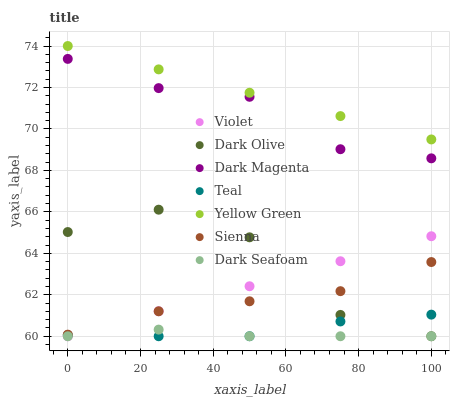Does Dark Seafoam have the minimum area under the curve?
Answer yes or no. Yes. Does Yellow Green have the maximum area under the curve?
Answer yes or no. Yes. Does Dark Olive have the minimum area under the curve?
Answer yes or no. No. Does Dark Olive have the maximum area under the curve?
Answer yes or no. No. Is Violet the smoothest?
Answer yes or no. Yes. Is Dark Olive the roughest?
Answer yes or no. Yes. Is Sienna the smoothest?
Answer yes or no. No. Is Sienna the roughest?
Answer yes or no. No. Does Dark Olive have the lowest value?
Answer yes or no. Yes. Does Sienna have the lowest value?
Answer yes or no. No. Does Yellow Green have the highest value?
Answer yes or no. Yes. Does Dark Olive have the highest value?
Answer yes or no. No. Is Violet less than Dark Magenta?
Answer yes or no. Yes. Is Yellow Green greater than Dark Olive?
Answer yes or no. Yes. Does Dark Olive intersect Sienna?
Answer yes or no. Yes. Is Dark Olive less than Sienna?
Answer yes or no. No. Is Dark Olive greater than Sienna?
Answer yes or no. No. Does Violet intersect Dark Magenta?
Answer yes or no. No. 